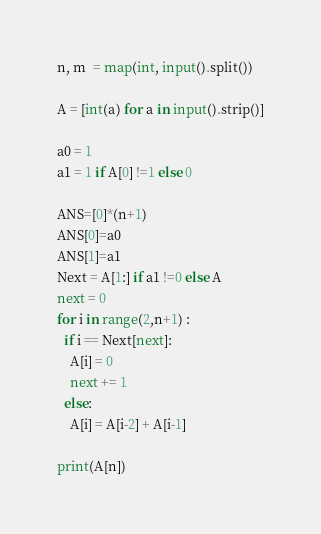Convert code to text. <code><loc_0><loc_0><loc_500><loc_500><_Python_>n, m  = map(int, input().split()) 

A = [int(a) for a in input().strip()]

a0 = 1 
a1 = 1 if A[0] !=1 else 0 

ANS=[0]*(n+1)
ANS[0]=a0
ANS[1]=a1
Next = A[1:] if a1 !=0 else A
next = 0
for i in range(2,n+1) :
  if i == Next[next]:
    A[i] = 0
    next += 1 
  else:
    A[i] = A[i-2] + A[i-1] 
  
print(A[n])</code> 